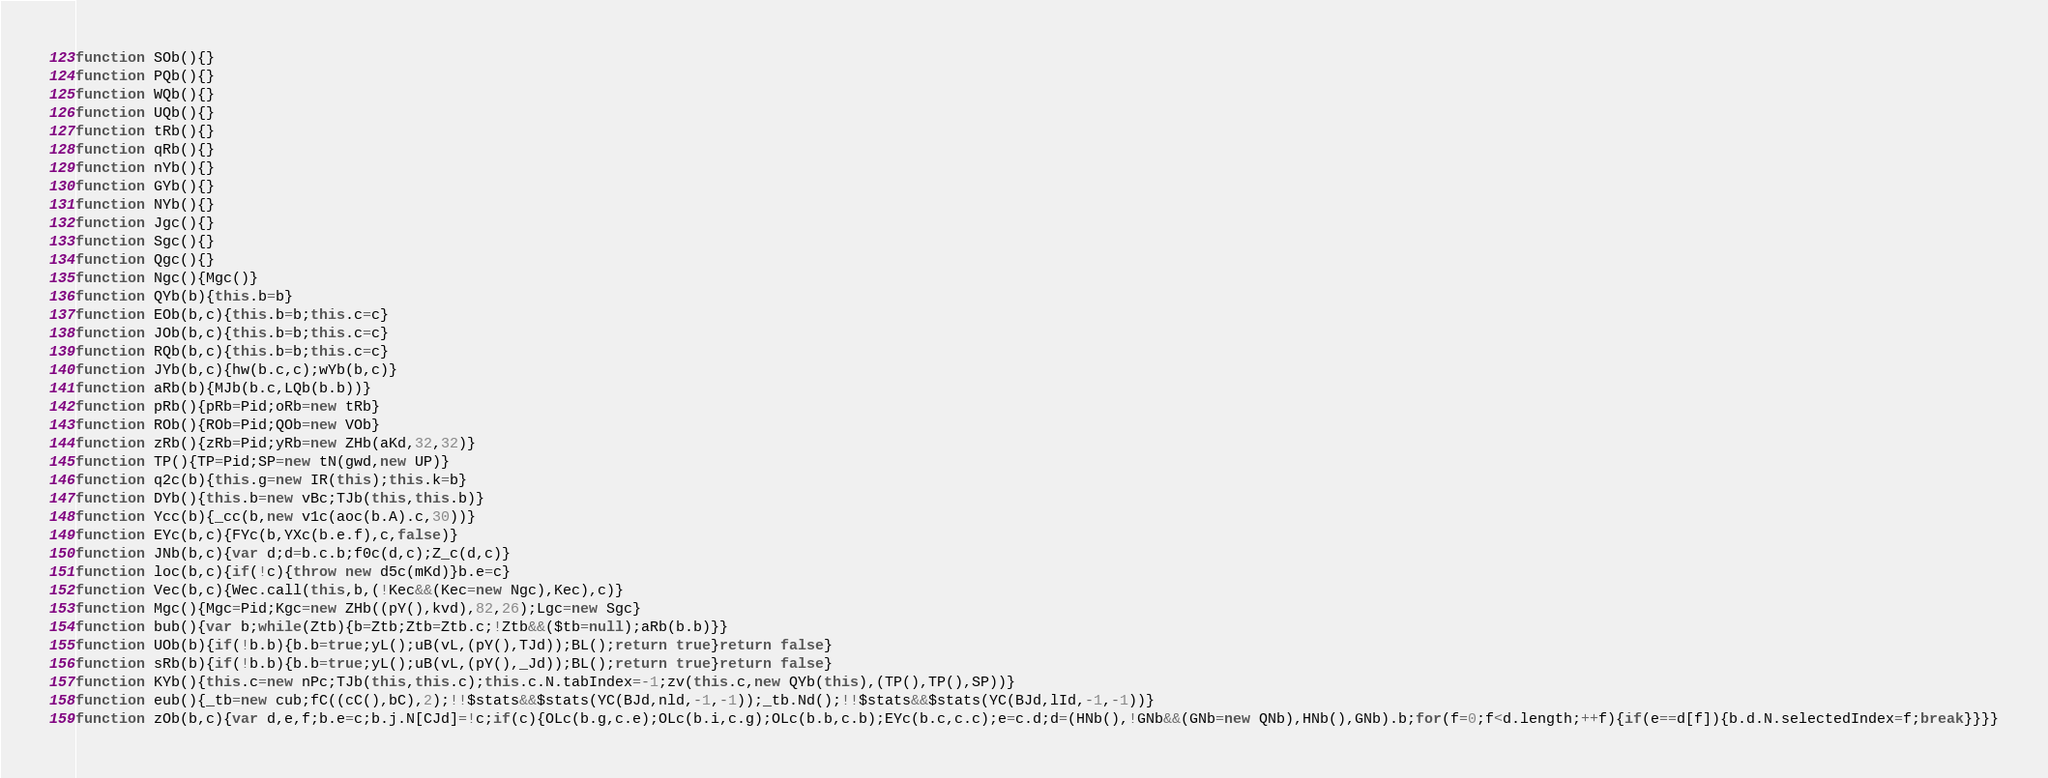<code> <loc_0><loc_0><loc_500><loc_500><_JavaScript_>function SOb(){}
function PQb(){}
function WQb(){}
function UQb(){}
function tRb(){}
function qRb(){}
function nYb(){}
function GYb(){}
function NYb(){}
function Jgc(){}
function Sgc(){}
function Qgc(){}
function Ngc(){Mgc()}
function QYb(b){this.b=b}
function EOb(b,c){this.b=b;this.c=c}
function JOb(b,c){this.b=b;this.c=c}
function RQb(b,c){this.b=b;this.c=c}
function JYb(b,c){hw(b.c,c);wYb(b,c)}
function aRb(b){MJb(b.c,LQb(b.b))}
function pRb(){pRb=Pid;oRb=new tRb}
function ROb(){ROb=Pid;QOb=new VOb}
function zRb(){zRb=Pid;yRb=new ZHb(aKd,32,32)}
function TP(){TP=Pid;SP=new tN(gwd,new UP)}
function q2c(b){this.g=new IR(this);this.k=b}
function DYb(){this.b=new vBc;TJb(this,this.b)}
function Ycc(b){_cc(b,new v1c(aoc(b.A).c,30))}
function EYc(b,c){FYc(b,YXc(b.e.f),c,false)}
function JNb(b,c){var d;d=b.c.b;f0c(d,c);Z_c(d,c)}
function loc(b,c){if(!c){throw new d5c(mKd)}b.e=c}
function Vec(b,c){Wec.call(this,b,(!Kec&&(Kec=new Ngc),Kec),c)}
function Mgc(){Mgc=Pid;Kgc=new ZHb((pY(),kvd),82,26);Lgc=new Sgc}
function bub(){var b;while(Ztb){b=Ztb;Ztb=Ztb.c;!Ztb&&($tb=null);aRb(b.b)}}
function UOb(b){if(!b.b){b.b=true;yL();uB(vL,(pY(),TJd));BL();return true}return false}
function sRb(b){if(!b.b){b.b=true;yL();uB(vL,(pY(),_Jd));BL();return true}return false}
function KYb(){this.c=new nPc;TJb(this,this.c);this.c.N.tabIndex=-1;zv(this.c,new QYb(this),(TP(),TP(),SP))}
function eub(){_tb=new cub;fC((cC(),bC),2);!!$stats&&$stats(YC(BJd,nld,-1,-1));_tb.Nd();!!$stats&&$stats(YC(BJd,lId,-1,-1))}
function zOb(b,c){var d,e,f;b.e=c;b.j.N[CJd]=!c;if(c){OLc(b.g,c.e);OLc(b.i,c.g);OLc(b.b,c.b);EYc(b.c,c.c);e=c.d;d=(HNb(),!GNb&&(GNb=new QNb),HNb(),GNb).b;for(f=0;f<d.length;++f){if(e==d[f]){b.d.N.selectedIndex=f;break}}}}</code> 